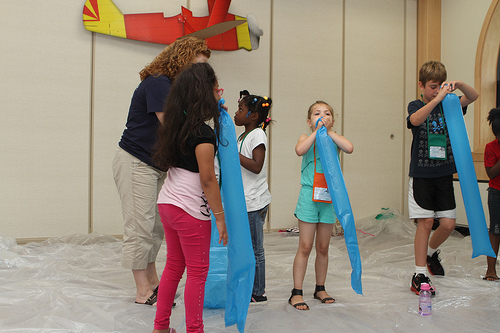<image>
Can you confirm if the balloon is in front of the boy? Yes. The balloon is positioned in front of the boy, appearing closer to the camera viewpoint. 